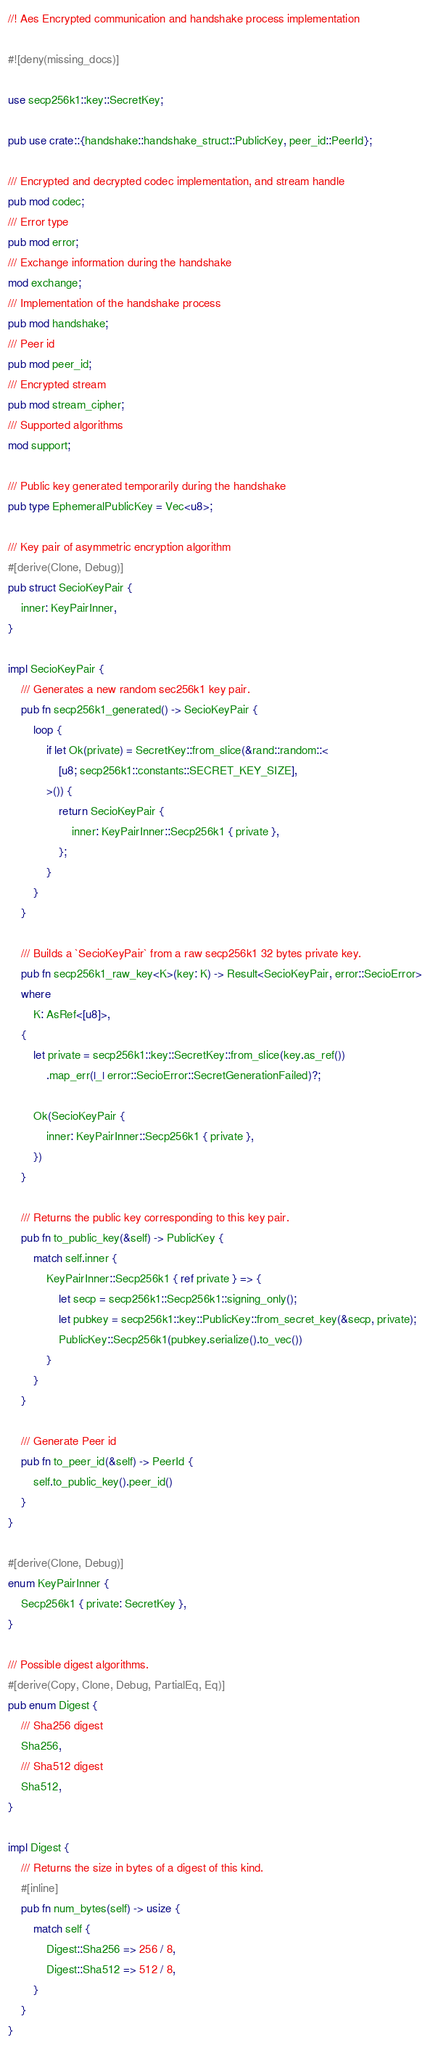<code> <loc_0><loc_0><loc_500><loc_500><_Rust_>//! Aes Encrypted communication and handshake process implementation

#![deny(missing_docs)]

use secp256k1::key::SecretKey;

pub use crate::{handshake::handshake_struct::PublicKey, peer_id::PeerId};

/// Encrypted and decrypted codec implementation, and stream handle
pub mod codec;
/// Error type
pub mod error;
/// Exchange information during the handshake
mod exchange;
/// Implementation of the handshake process
pub mod handshake;
/// Peer id
pub mod peer_id;
/// Encrypted stream
pub mod stream_cipher;
/// Supported algorithms
mod support;

/// Public key generated temporarily during the handshake
pub type EphemeralPublicKey = Vec<u8>;

/// Key pair of asymmetric encryption algorithm
#[derive(Clone, Debug)]
pub struct SecioKeyPair {
    inner: KeyPairInner,
}

impl SecioKeyPair {
    /// Generates a new random sec256k1 key pair.
    pub fn secp256k1_generated() -> SecioKeyPair {
        loop {
            if let Ok(private) = SecretKey::from_slice(&rand::random::<
                [u8; secp256k1::constants::SECRET_KEY_SIZE],
            >()) {
                return SecioKeyPair {
                    inner: KeyPairInner::Secp256k1 { private },
                };
            }
        }
    }

    /// Builds a `SecioKeyPair` from a raw secp256k1 32 bytes private key.
    pub fn secp256k1_raw_key<K>(key: K) -> Result<SecioKeyPair, error::SecioError>
    where
        K: AsRef<[u8]>,
    {
        let private = secp256k1::key::SecretKey::from_slice(key.as_ref())
            .map_err(|_| error::SecioError::SecretGenerationFailed)?;

        Ok(SecioKeyPair {
            inner: KeyPairInner::Secp256k1 { private },
        })
    }

    /// Returns the public key corresponding to this key pair.
    pub fn to_public_key(&self) -> PublicKey {
        match self.inner {
            KeyPairInner::Secp256k1 { ref private } => {
                let secp = secp256k1::Secp256k1::signing_only();
                let pubkey = secp256k1::key::PublicKey::from_secret_key(&secp, private);
                PublicKey::Secp256k1(pubkey.serialize().to_vec())
            }
        }
    }

    /// Generate Peer id
    pub fn to_peer_id(&self) -> PeerId {
        self.to_public_key().peer_id()
    }
}

#[derive(Clone, Debug)]
enum KeyPairInner {
    Secp256k1 { private: SecretKey },
}

/// Possible digest algorithms.
#[derive(Copy, Clone, Debug, PartialEq, Eq)]
pub enum Digest {
    /// Sha256 digest
    Sha256,
    /// Sha512 digest
    Sha512,
}

impl Digest {
    /// Returns the size in bytes of a digest of this kind.
    #[inline]
    pub fn num_bytes(self) -> usize {
        match self {
            Digest::Sha256 => 256 / 8,
            Digest::Sha512 => 512 / 8,
        }
    }
}
</code> 